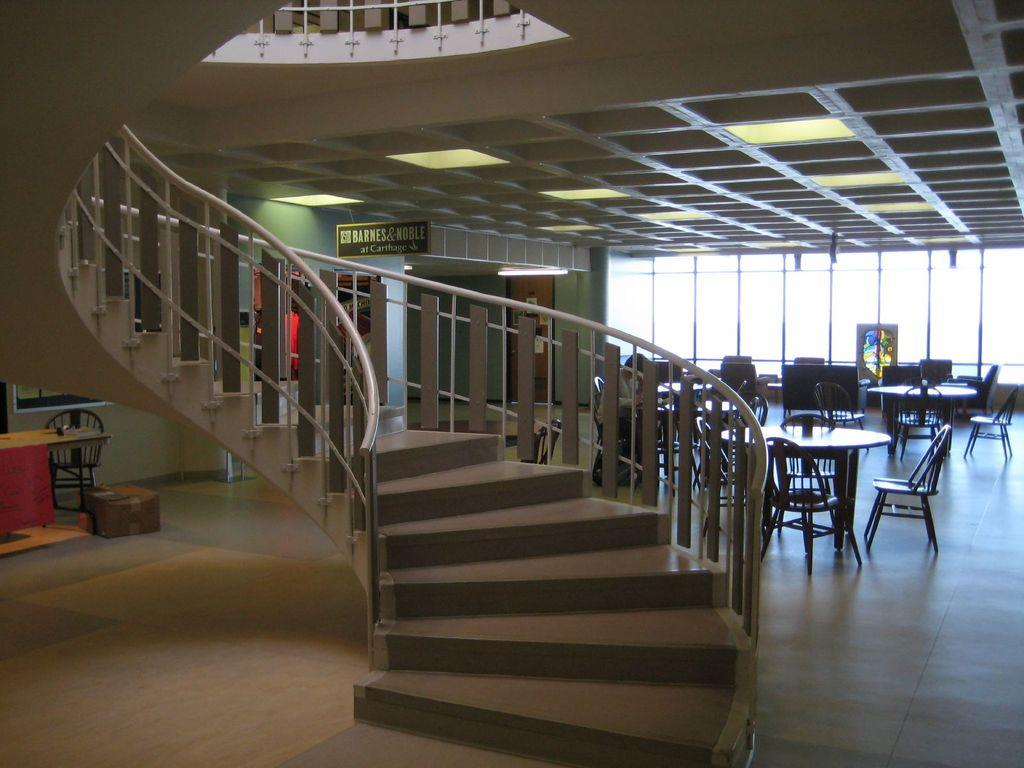What celestial objects can be seen in the image? There are stars visible in the image. What type of furniture is present in the image? There are tables and chairs in the image. What type of signage or display is present in the image? There are boards in the image. What type of illumination is present in the image? There are lights in the image. What type of container is present in the image? There is a cardboard box in the image. What other objects can be seen in the image? There are some objects in the image. Can you see a gate in the image? There is no gate present in the image. What type of slip is visible on the chairs in the image? There are no slips on the chairs in the image. 